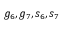Convert formula to latex. <formula><loc_0><loc_0><loc_500><loc_500>g _ { 6 } , g _ { 7 } , s _ { 6 } , s _ { 7 }</formula> 